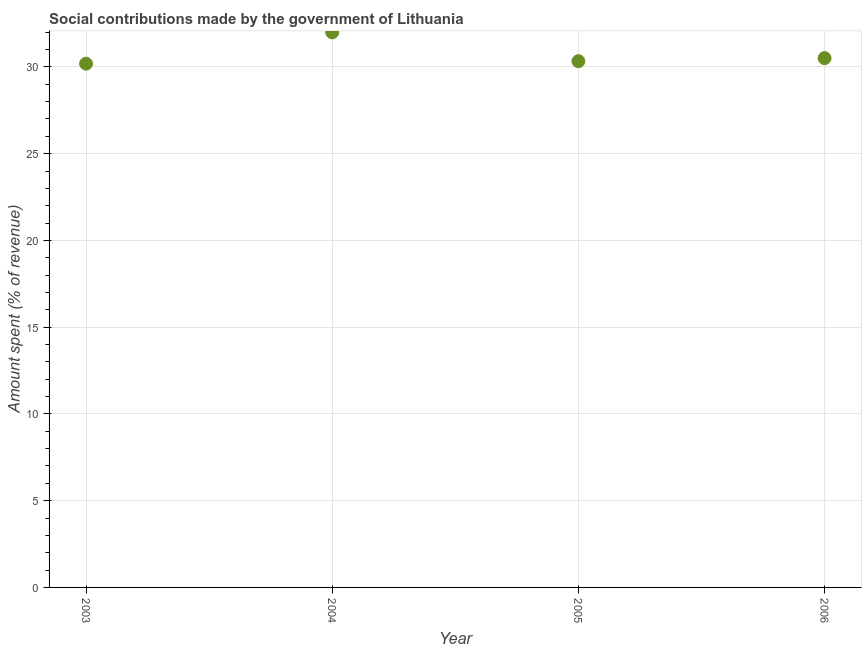What is the amount spent in making social contributions in 2005?
Ensure brevity in your answer.  30.33. Across all years, what is the maximum amount spent in making social contributions?
Your answer should be compact. 31.99. Across all years, what is the minimum amount spent in making social contributions?
Provide a succinct answer. 30.19. In which year was the amount spent in making social contributions minimum?
Make the answer very short. 2003. What is the sum of the amount spent in making social contributions?
Provide a succinct answer. 123.02. What is the difference between the amount spent in making social contributions in 2003 and 2006?
Your answer should be very brief. -0.32. What is the average amount spent in making social contributions per year?
Your answer should be very brief. 30.76. What is the median amount spent in making social contributions?
Provide a succinct answer. 30.42. What is the ratio of the amount spent in making social contributions in 2003 to that in 2004?
Give a very brief answer. 0.94. Is the difference between the amount spent in making social contributions in 2004 and 2005 greater than the difference between any two years?
Your response must be concise. No. What is the difference between the highest and the second highest amount spent in making social contributions?
Provide a succinct answer. 1.48. Is the sum of the amount spent in making social contributions in 2003 and 2006 greater than the maximum amount spent in making social contributions across all years?
Your answer should be very brief. Yes. What is the difference between the highest and the lowest amount spent in making social contributions?
Provide a short and direct response. 1.8. How many dotlines are there?
Your answer should be very brief. 1. What is the difference between two consecutive major ticks on the Y-axis?
Your answer should be very brief. 5. Are the values on the major ticks of Y-axis written in scientific E-notation?
Your answer should be very brief. No. Does the graph contain any zero values?
Provide a succinct answer. No. Does the graph contain grids?
Provide a short and direct response. Yes. What is the title of the graph?
Give a very brief answer. Social contributions made by the government of Lithuania. What is the label or title of the X-axis?
Provide a succinct answer. Year. What is the label or title of the Y-axis?
Give a very brief answer. Amount spent (% of revenue). What is the Amount spent (% of revenue) in 2003?
Your response must be concise. 30.19. What is the Amount spent (% of revenue) in 2004?
Give a very brief answer. 31.99. What is the Amount spent (% of revenue) in 2005?
Give a very brief answer. 30.33. What is the Amount spent (% of revenue) in 2006?
Your response must be concise. 30.51. What is the difference between the Amount spent (% of revenue) in 2003 and 2004?
Your response must be concise. -1.8. What is the difference between the Amount spent (% of revenue) in 2003 and 2005?
Offer a very short reply. -0.14. What is the difference between the Amount spent (% of revenue) in 2003 and 2006?
Provide a succinct answer. -0.32. What is the difference between the Amount spent (% of revenue) in 2004 and 2005?
Your answer should be compact. 1.66. What is the difference between the Amount spent (% of revenue) in 2004 and 2006?
Give a very brief answer. 1.48. What is the difference between the Amount spent (% of revenue) in 2005 and 2006?
Offer a terse response. -0.18. What is the ratio of the Amount spent (% of revenue) in 2003 to that in 2004?
Your answer should be compact. 0.94. What is the ratio of the Amount spent (% of revenue) in 2003 to that in 2005?
Provide a succinct answer. 0.99. What is the ratio of the Amount spent (% of revenue) in 2003 to that in 2006?
Provide a short and direct response. 0.99. What is the ratio of the Amount spent (% of revenue) in 2004 to that in 2005?
Your answer should be very brief. 1.05. What is the ratio of the Amount spent (% of revenue) in 2004 to that in 2006?
Offer a very short reply. 1.05. What is the ratio of the Amount spent (% of revenue) in 2005 to that in 2006?
Keep it short and to the point. 0.99. 